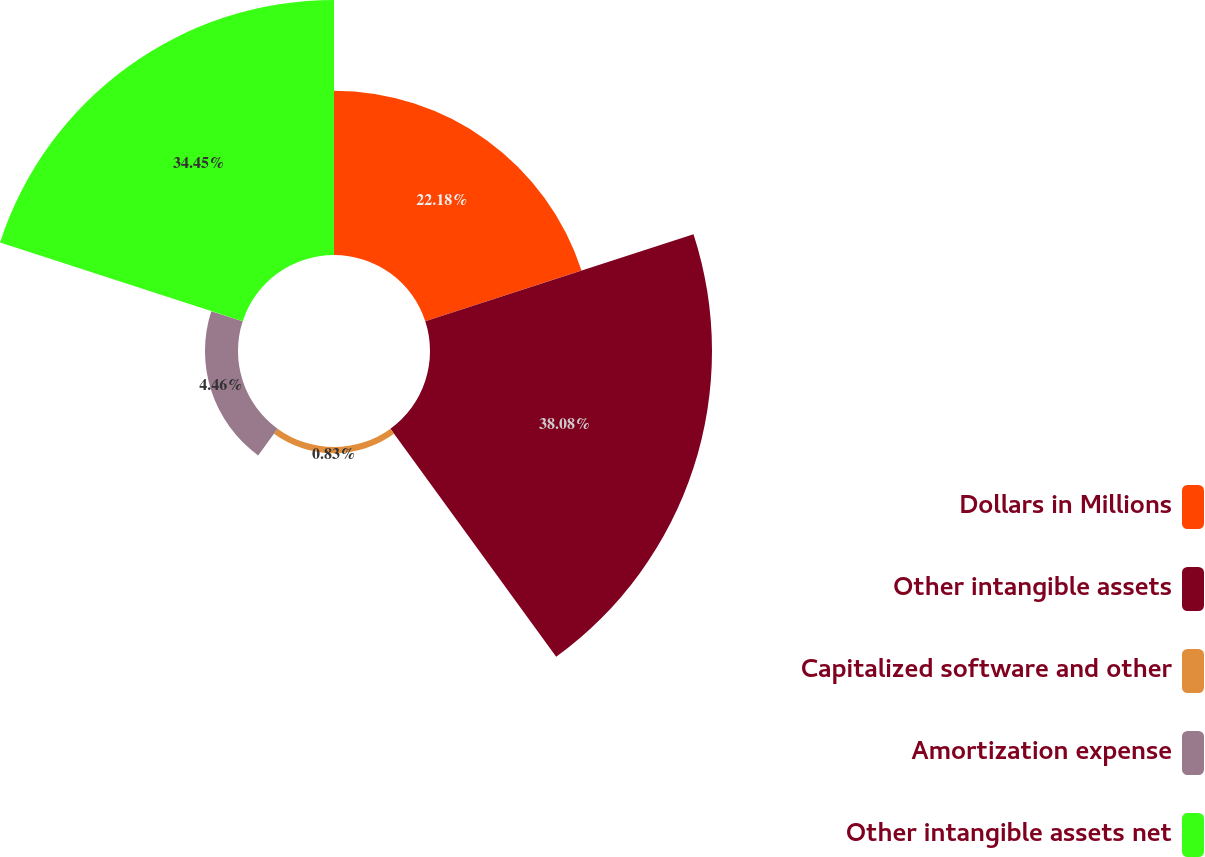Convert chart. <chart><loc_0><loc_0><loc_500><loc_500><pie_chart><fcel>Dollars in Millions<fcel>Other intangible assets<fcel>Capitalized software and other<fcel>Amortization expense<fcel>Other intangible assets net<nl><fcel>22.18%<fcel>38.08%<fcel>0.83%<fcel>4.46%<fcel>34.45%<nl></chart> 